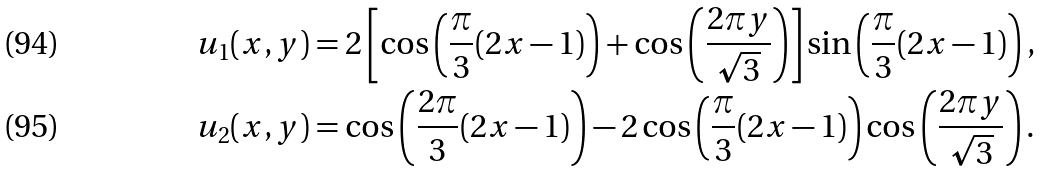<formula> <loc_0><loc_0><loc_500><loc_500>u _ { 1 } ( x , y ) & = 2 \left [ \cos \left ( \frac { \pi } { 3 } ( 2 x - 1 ) \right ) + \cos \left ( \frac { 2 \pi y } { \sqrt { 3 } } \right ) \right ] \sin \left ( \frac { \pi } { 3 } ( 2 x - 1 ) \right ) , \\ u _ { 2 } ( x , y ) & = \cos \left ( \frac { 2 \pi } 3 ( 2 x - 1 ) \right ) - 2 \cos \left ( \frac { \pi } { 3 } ( 2 x - 1 ) \right ) \cos \left ( \frac { 2 \pi y } { \sqrt { 3 } } \right ) .</formula> 